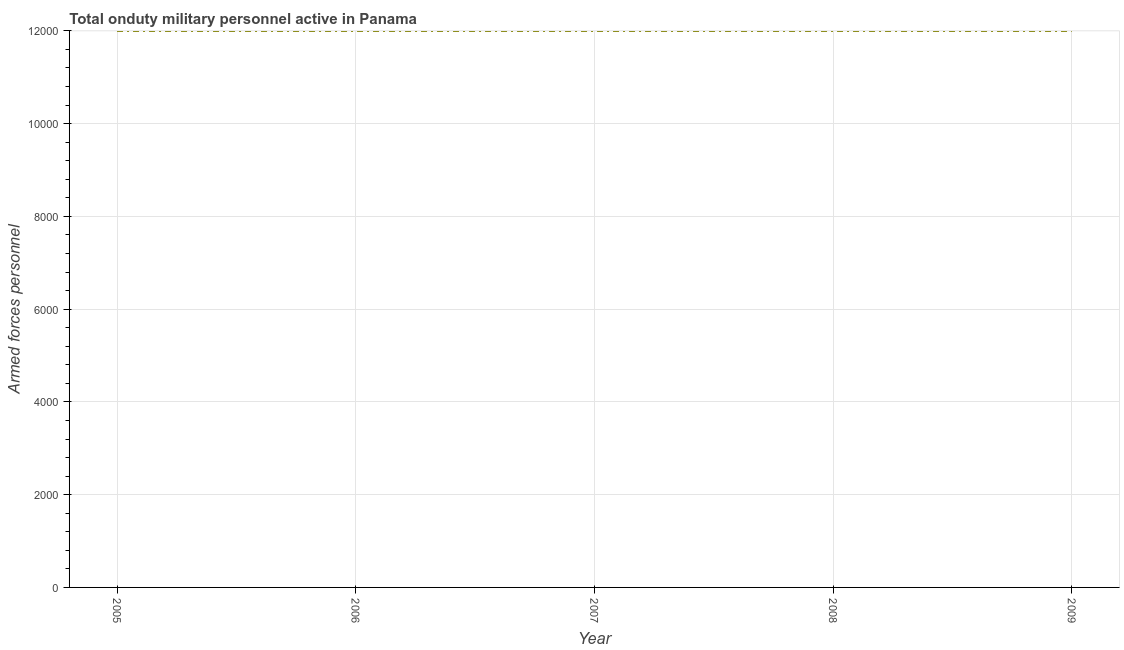What is the number of armed forces personnel in 2007?
Provide a succinct answer. 1.20e+04. Across all years, what is the maximum number of armed forces personnel?
Offer a very short reply. 1.20e+04. Across all years, what is the minimum number of armed forces personnel?
Offer a terse response. 1.20e+04. In which year was the number of armed forces personnel maximum?
Ensure brevity in your answer.  2005. What is the sum of the number of armed forces personnel?
Offer a very short reply. 6.00e+04. What is the difference between the number of armed forces personnel in 2006 and 2009?
Make the answer very short. 0. What is the average number of armed forces personnel per year?
Give a very brief answer. 1.20e+04. What is the median number of armed forces personnel?
Your answer should be compact. 1.20e+04. In how many years, is the number of armed forces personnel greater than 5600 ?
Provide a short and direct response. 5. Is the number of armed forces personnel in 2005 less than that in 2008?
Offer a terse response. No. Is the difference between the number of armed forces personnel in 2008 and 2009 greater than the difference between any two years?
Make the answer very short. Yes. What is the difference between the highest and the lowest number of armed forces personnel?
Your response must be concise. 0. How many years are there in the graph?
Provide a short and direct response. 5. Does the graph contain grids?
Your response must be concise. Yes. What is the title of the graph?
Ensure brevity in your answer.  Total onduty military personnel active in Panama. What is the label or title of the X-axis?
Offer a terse response. Year. What is the label or title of the Y-axis?
Your response must be concise. Armed forces personnel. What is the Armed forces personnel of 2005?
Provide a succinct answer. 1.20e+04. What is the Armed forces personnel of 2006?
Your response must be concise. 1.20e+04. What is the Armed forces personnel in 2007?
Give a very brief answer. 1.20e+04. What is the Armed forces personnel in 2008?
Give a very brief answer. 1.20e+04. What is the Armed forces personnel in 2009?
Your answer should be compact. 1.20e+04. What is the difference between the Armed forces personnel in 2005 and 2008?
Provide a short and direct response. 0. What is the difference between the Armed forces personnel in 2005 and 2009?
Your response must be concise. 0. What is the difference between the Armed forces personnel in 2007 and 2008?
Ensure brevity in your answer.  0. What is the difference between the Armed forces personnel in 2008 and 2009?
Your answer should be very brief. 0. What is the ratio of the Armed forces personnel in 2005 to that in 2007?
Keep it short and to the point. 1. What is the ratio of the Armed forces personnel in 2005 to that in 2008?
Your response must be concise. 1. What is the ratio of the Armed forces personnel in 2006 to that in 2007?
Your response must be concise. 1. What is the ratio of the Armed forces personnel in 2007 to that in 2008?
Provide a succinct answer. 1. What is the ratio of the Armed forces personnel in 2008 to that in 2009?
Your answer should be compact. 1. 